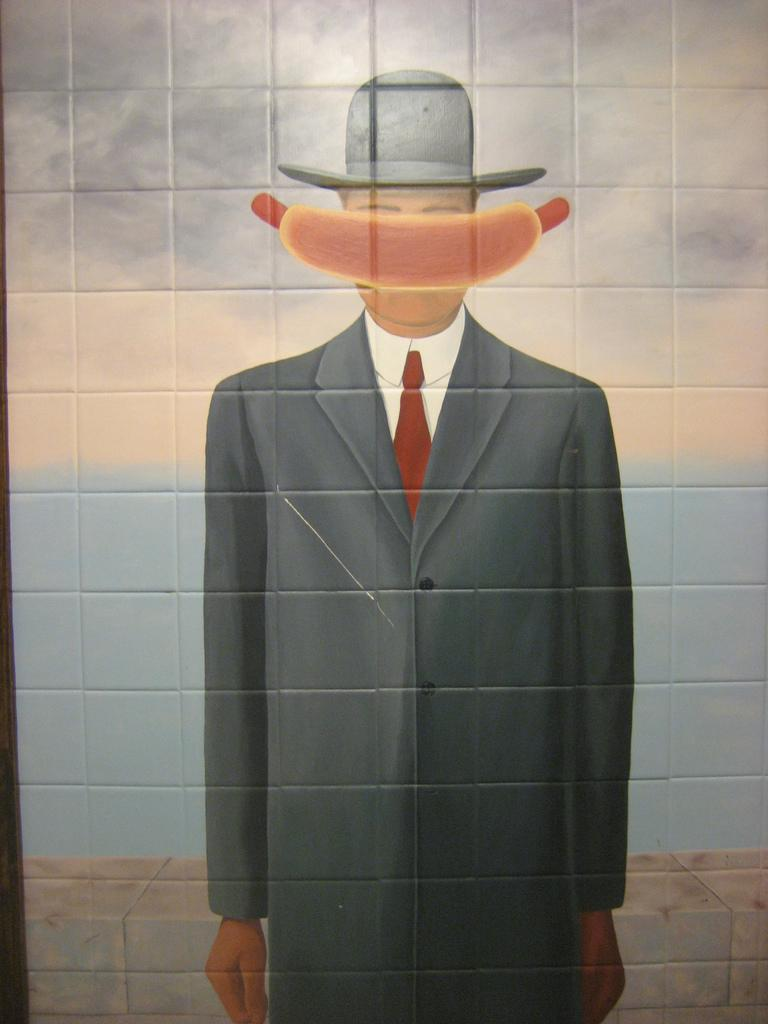What is the main subject of the image? There is a painting in the image. What does the painting depict? The painting depicts a human. Where is the painting located? The painting is on a wall. How many bones can be seen in the painting? There are no bones visible in the painting; it depicts a human figure. Can you tell me how many times the person in the painting sneezes? There is no indication of the person in the painting sneezing, as it is a static image. 